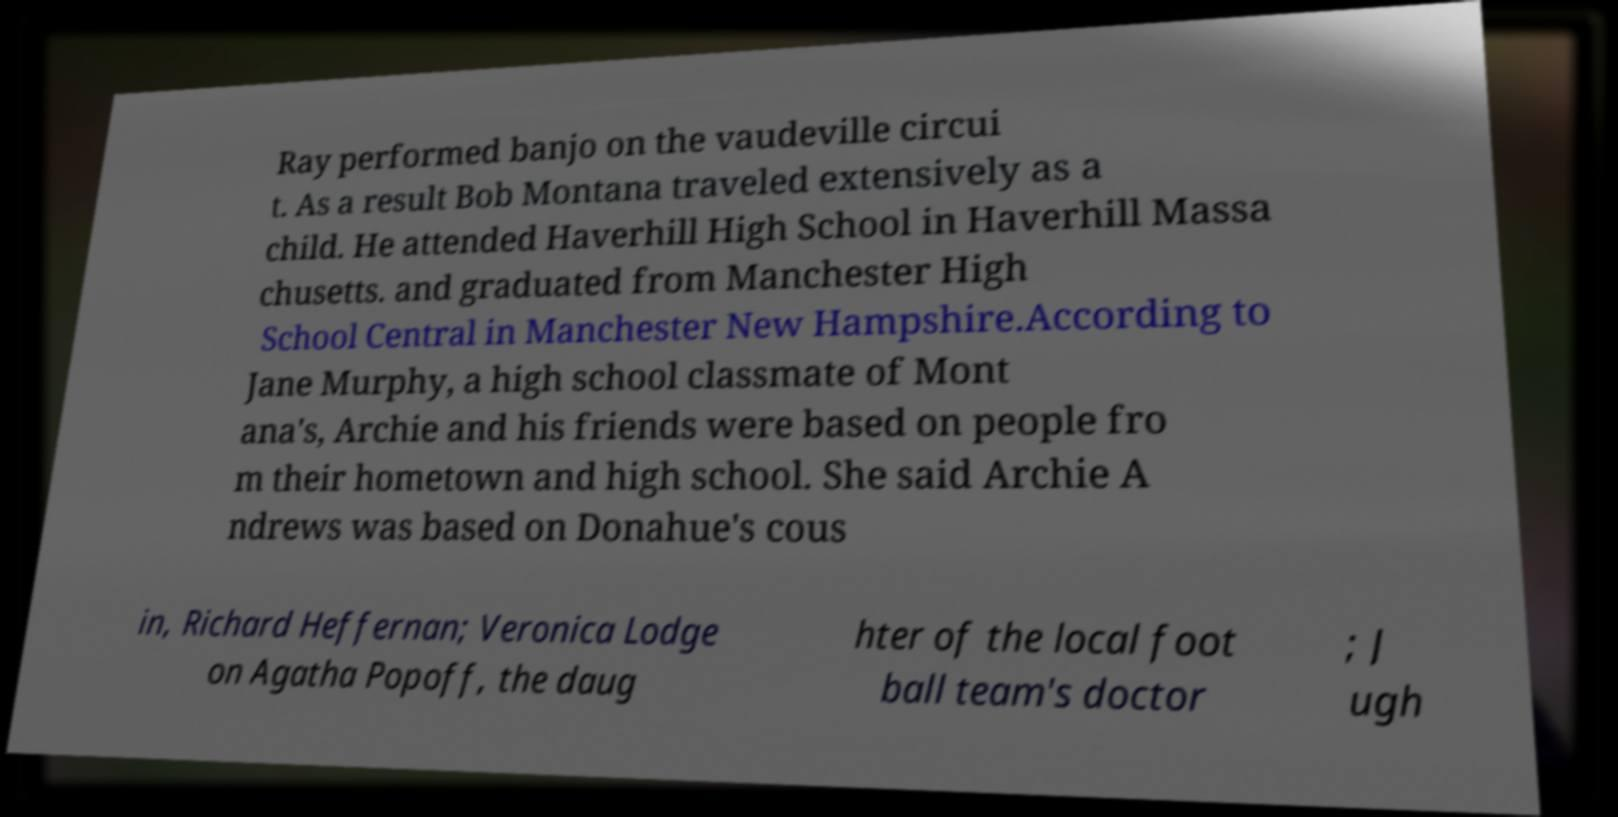What messages or text are displayed in this image? I need them in a readable, typed format. Ray performed banjo on the vaudeville circui t. As a result Bob Montana traveled extensively as a child. He attended Haverhill High School in Haverhill Massa chusetts. and graduated from Manchester High School Central in Manchester New Hampshire.According to Jane Murphy, a high school classmate of Mont ana's, Archie and his friends were based on people fro m their hometown and high school. She said Archie A ndrews was based on Donahue's cous in, Richard Heffernan; Veronica Lodge on Agatha Popoff, the daug hter of the local foot ball team's doctor ; J ugh 